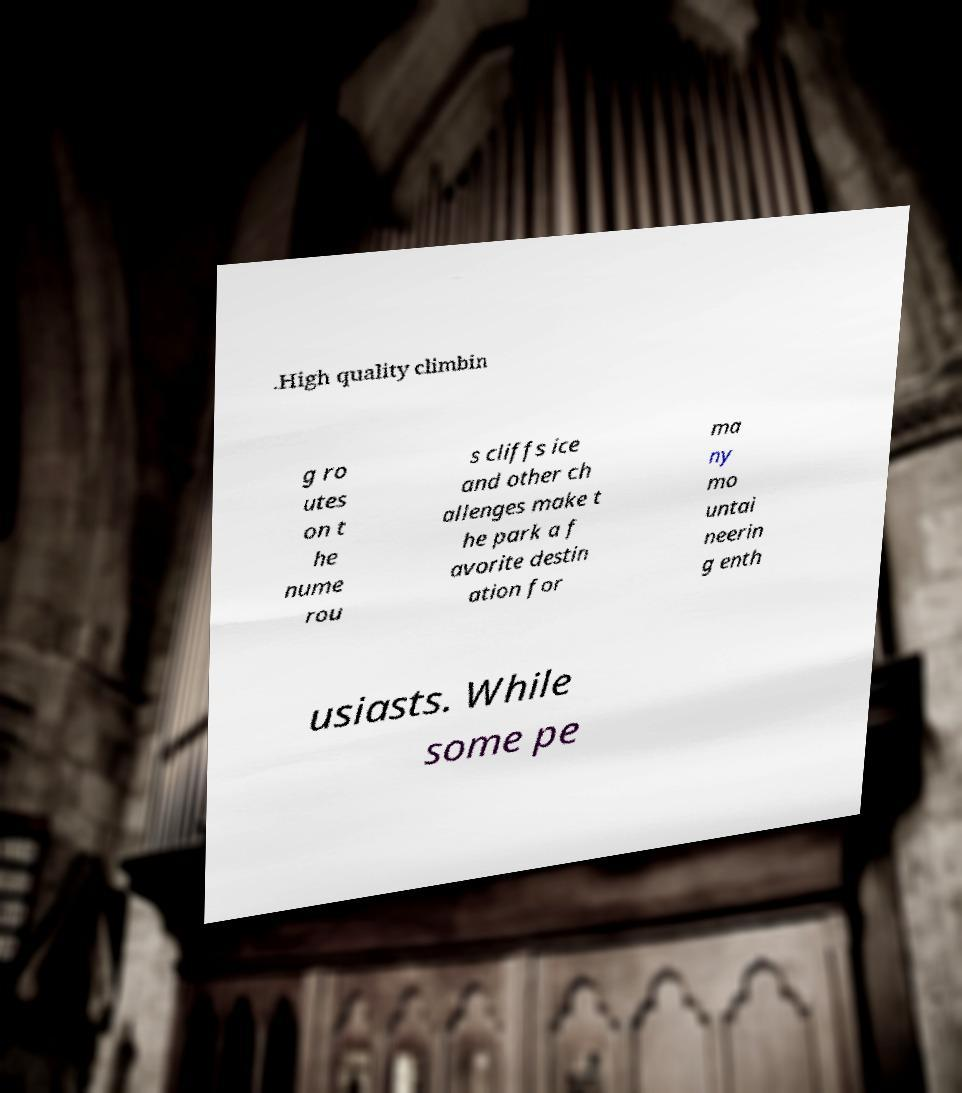Please read and relay the text visible in this image. What does it say? .High quality climbin g ro utes on t he nume rou s cliffs ice and other ch allenges make t he park a f avorite destin ation for ma ny mo untai neerin g enth usiasts. While some pe 